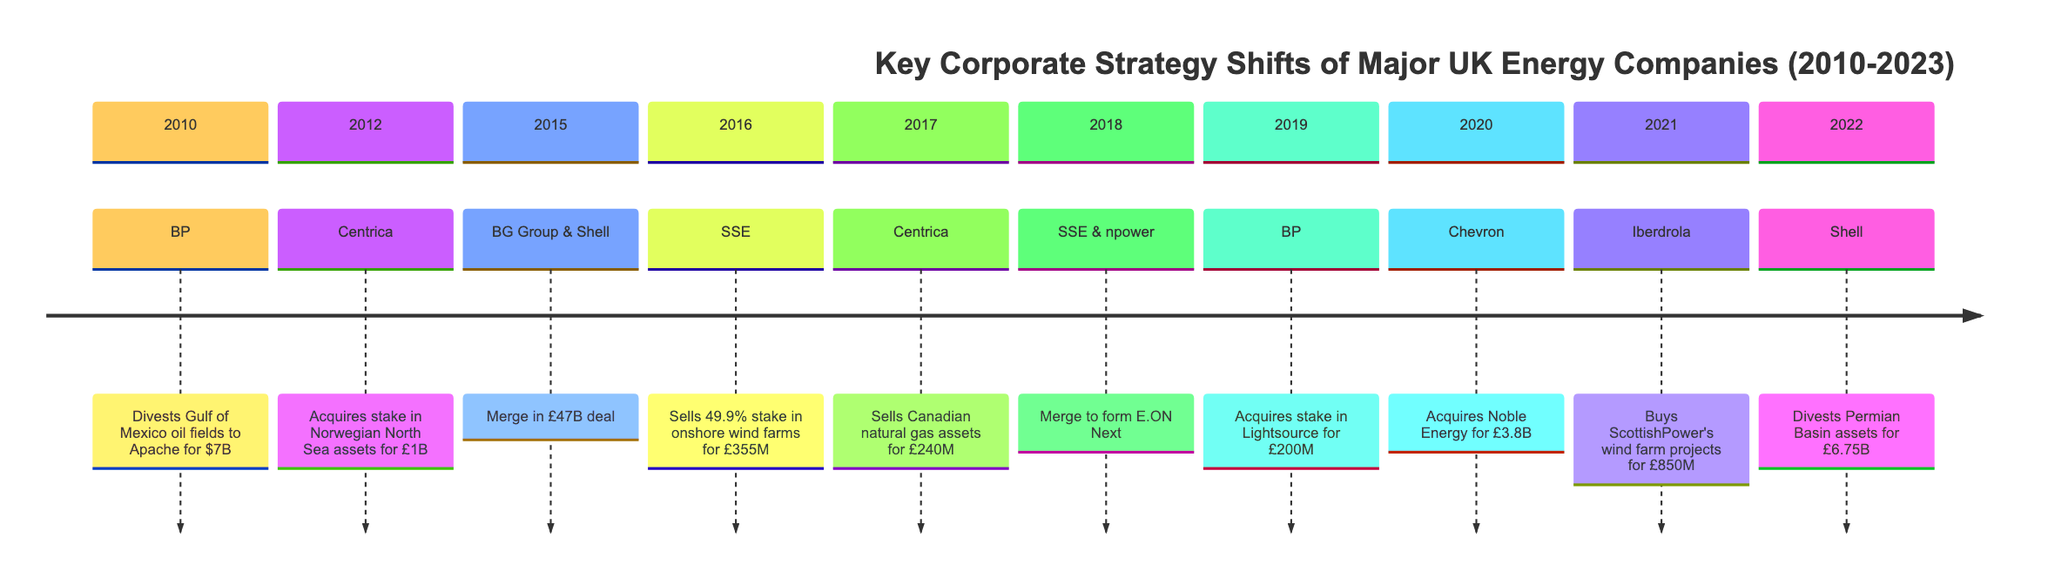What was the value of BP's divestiture in 2010? According to the timeline, BP completed the sale of its interests in four Gulf of Mexico oil fields for $7 billion in 2010.
Answer: $7 billion How much did Centrica spend to acquire a stake in Norwegian assets in 2012? The timeline states that Centrica acquired a stake in Norwegian North Sea oil and gas assets from Statoil for £1 billion in 2012.
Answer: £1 billion Which two companies merged in 2015? The timeline records that BG Group merged with Royal Dutch Shell in a deal valued at £47 billion in 2015.
Answer: BG Group & Royal Dutch Shell What event involved SSE in 2018? SSE and npower merged to create a new retail energy company, E.ON Next, in 2018, as per the timeline events.
Answer: Merge to create E.ON Next Which company divested assets in 2022? The timeline indicates that Shell divested its Permian Basin assets in 2022 as part of its strategy to shift towards renewable energy.
Answer: Shell What is the total number of divestitures listed in the timeline? By examining the timeline, there are four distinct events classified as divestitures: BP in 2010, SSE in 2016, Centrica in 2017, and Shell in 2022.
Answer: 4 Which company acquired Noble Energy in 2020? The timeline shows that Chevron completed the acquisition of Noble Energy for £3.8 billion in 2020, as noted in the events.
Answer: Chevron What does the merger of SSE and npower signify in terms of corporate strategy? The merger signifies a strategic consolidation in the UK energy market to create a more competitive entity, highlighted in the timeline as a merge forming E.ON Next.
Answer: Creation of E.ON Next Which event marked Centrica's restructuring in 2017? The timeline describes that Centrica restructured its business and sold its Canadian natural gas assets in 2017, marking a significant strategic shift.
Answer: Sells Canadian natural gas assets 